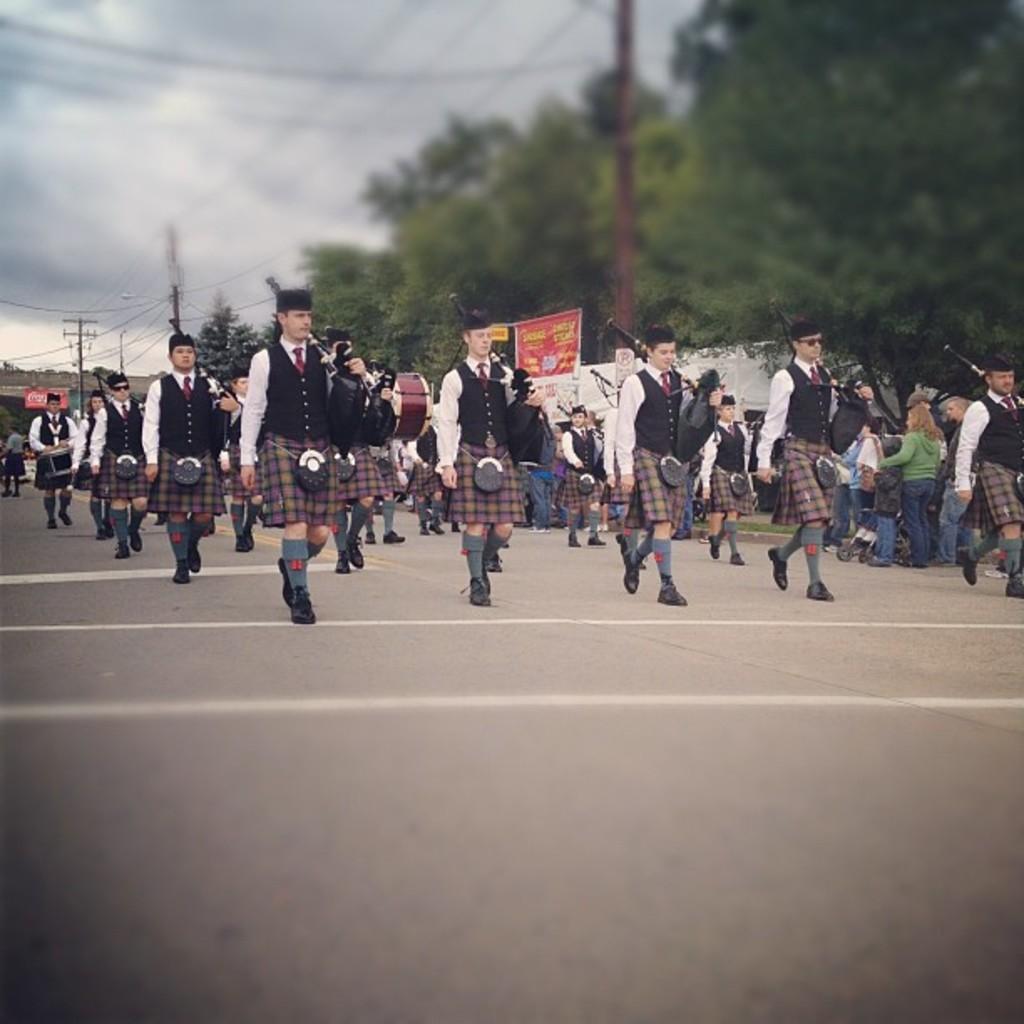How would you summarize this image in a sentence or two? In this picture I can see there are a group of people walking here and they are wearing uniforms and they are holding weapons and in the backdrop there are banners, trees and there are electric poles connected with wires and the sky is clear. 